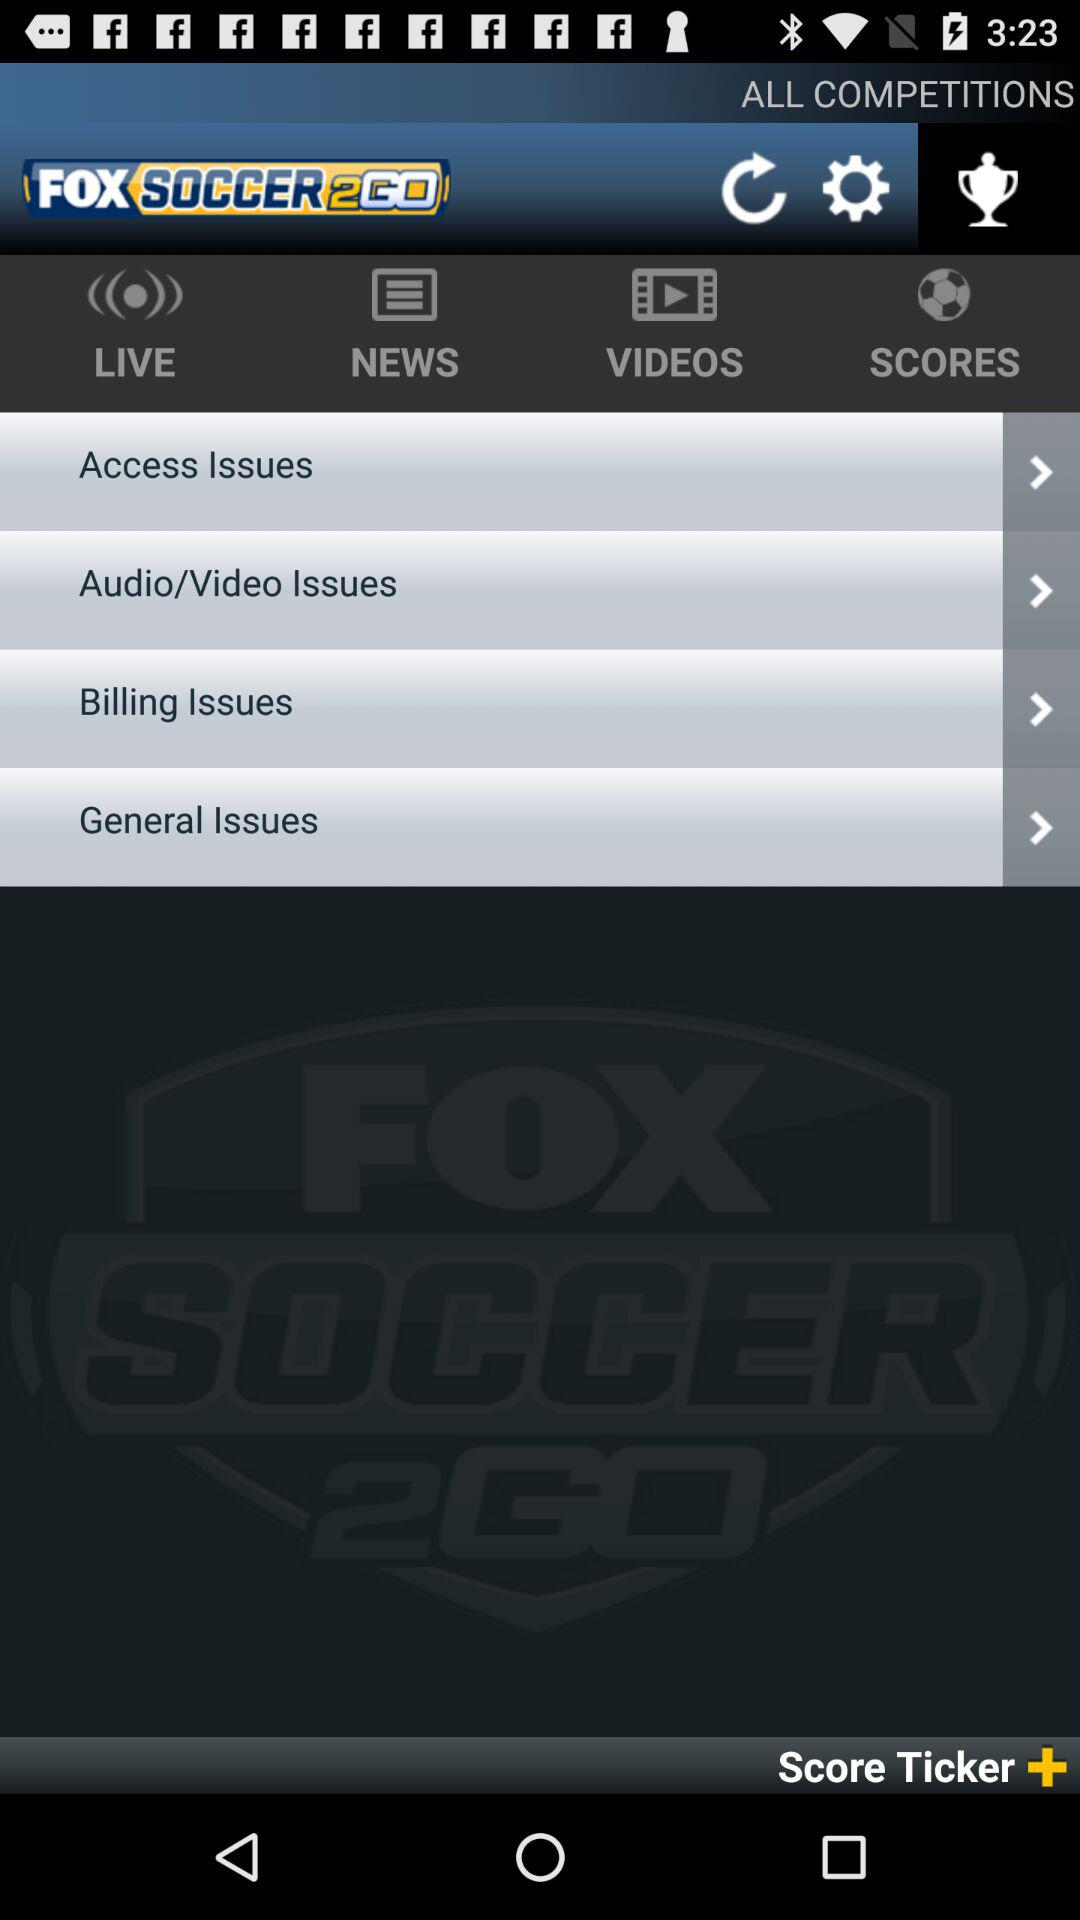What are the top videos that are available?
When the provided information is insufficient, respond with <no answer>. <no answer> 